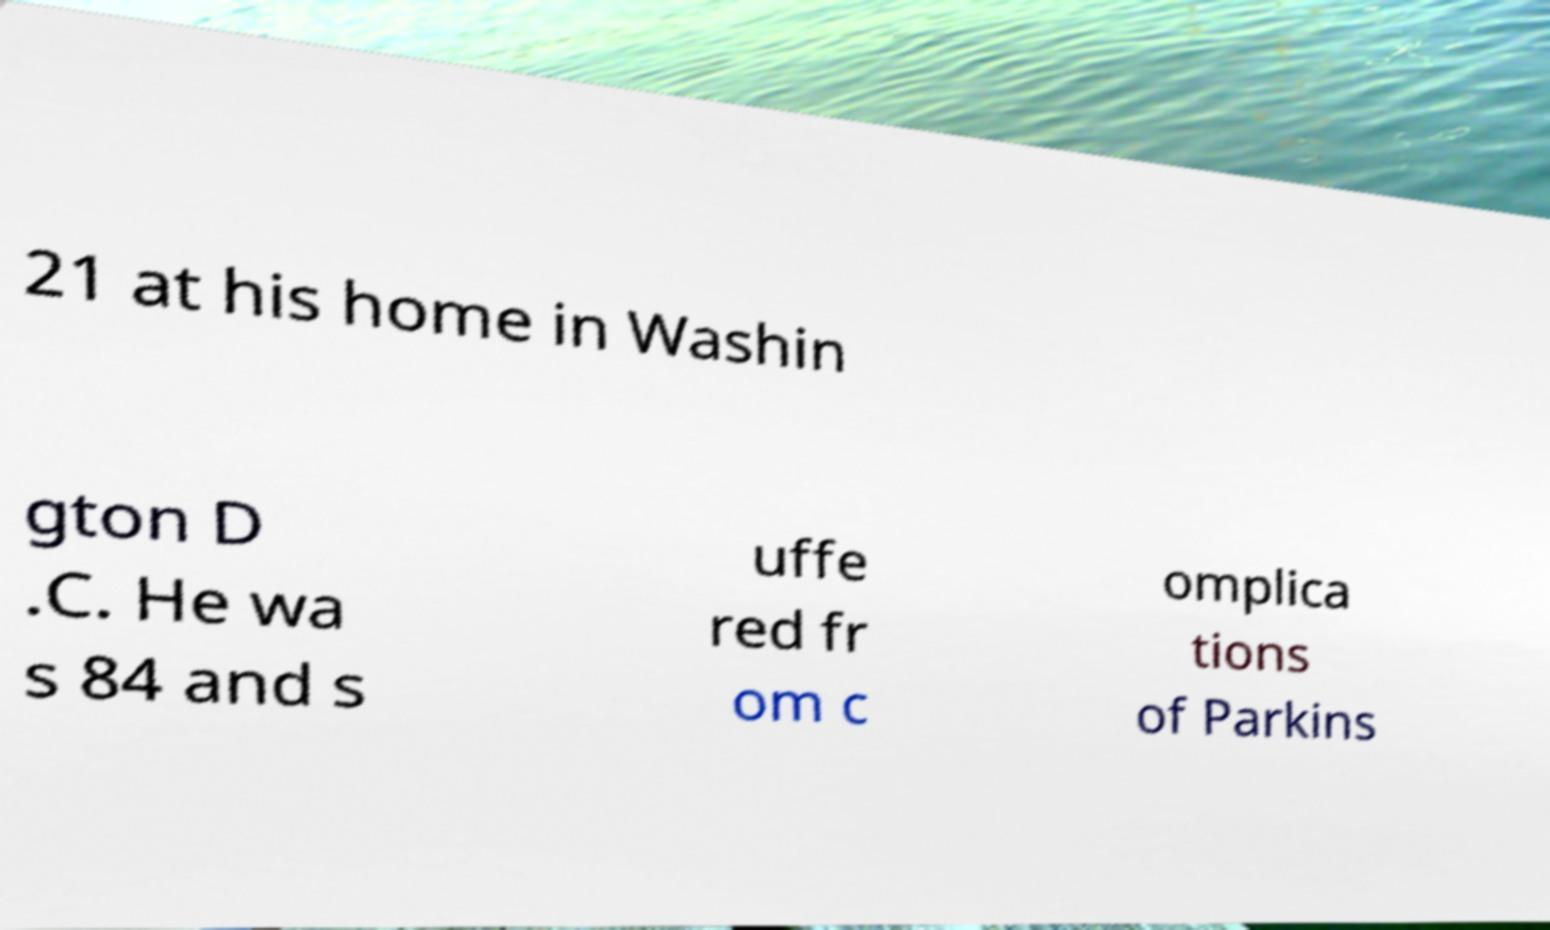What messages or text are displayed in this image? I need them in a readable, typed format. 21 at his home in Washin gton D .C. He wa s 84 and s uffe red fr om c omplica tions of Parkins 